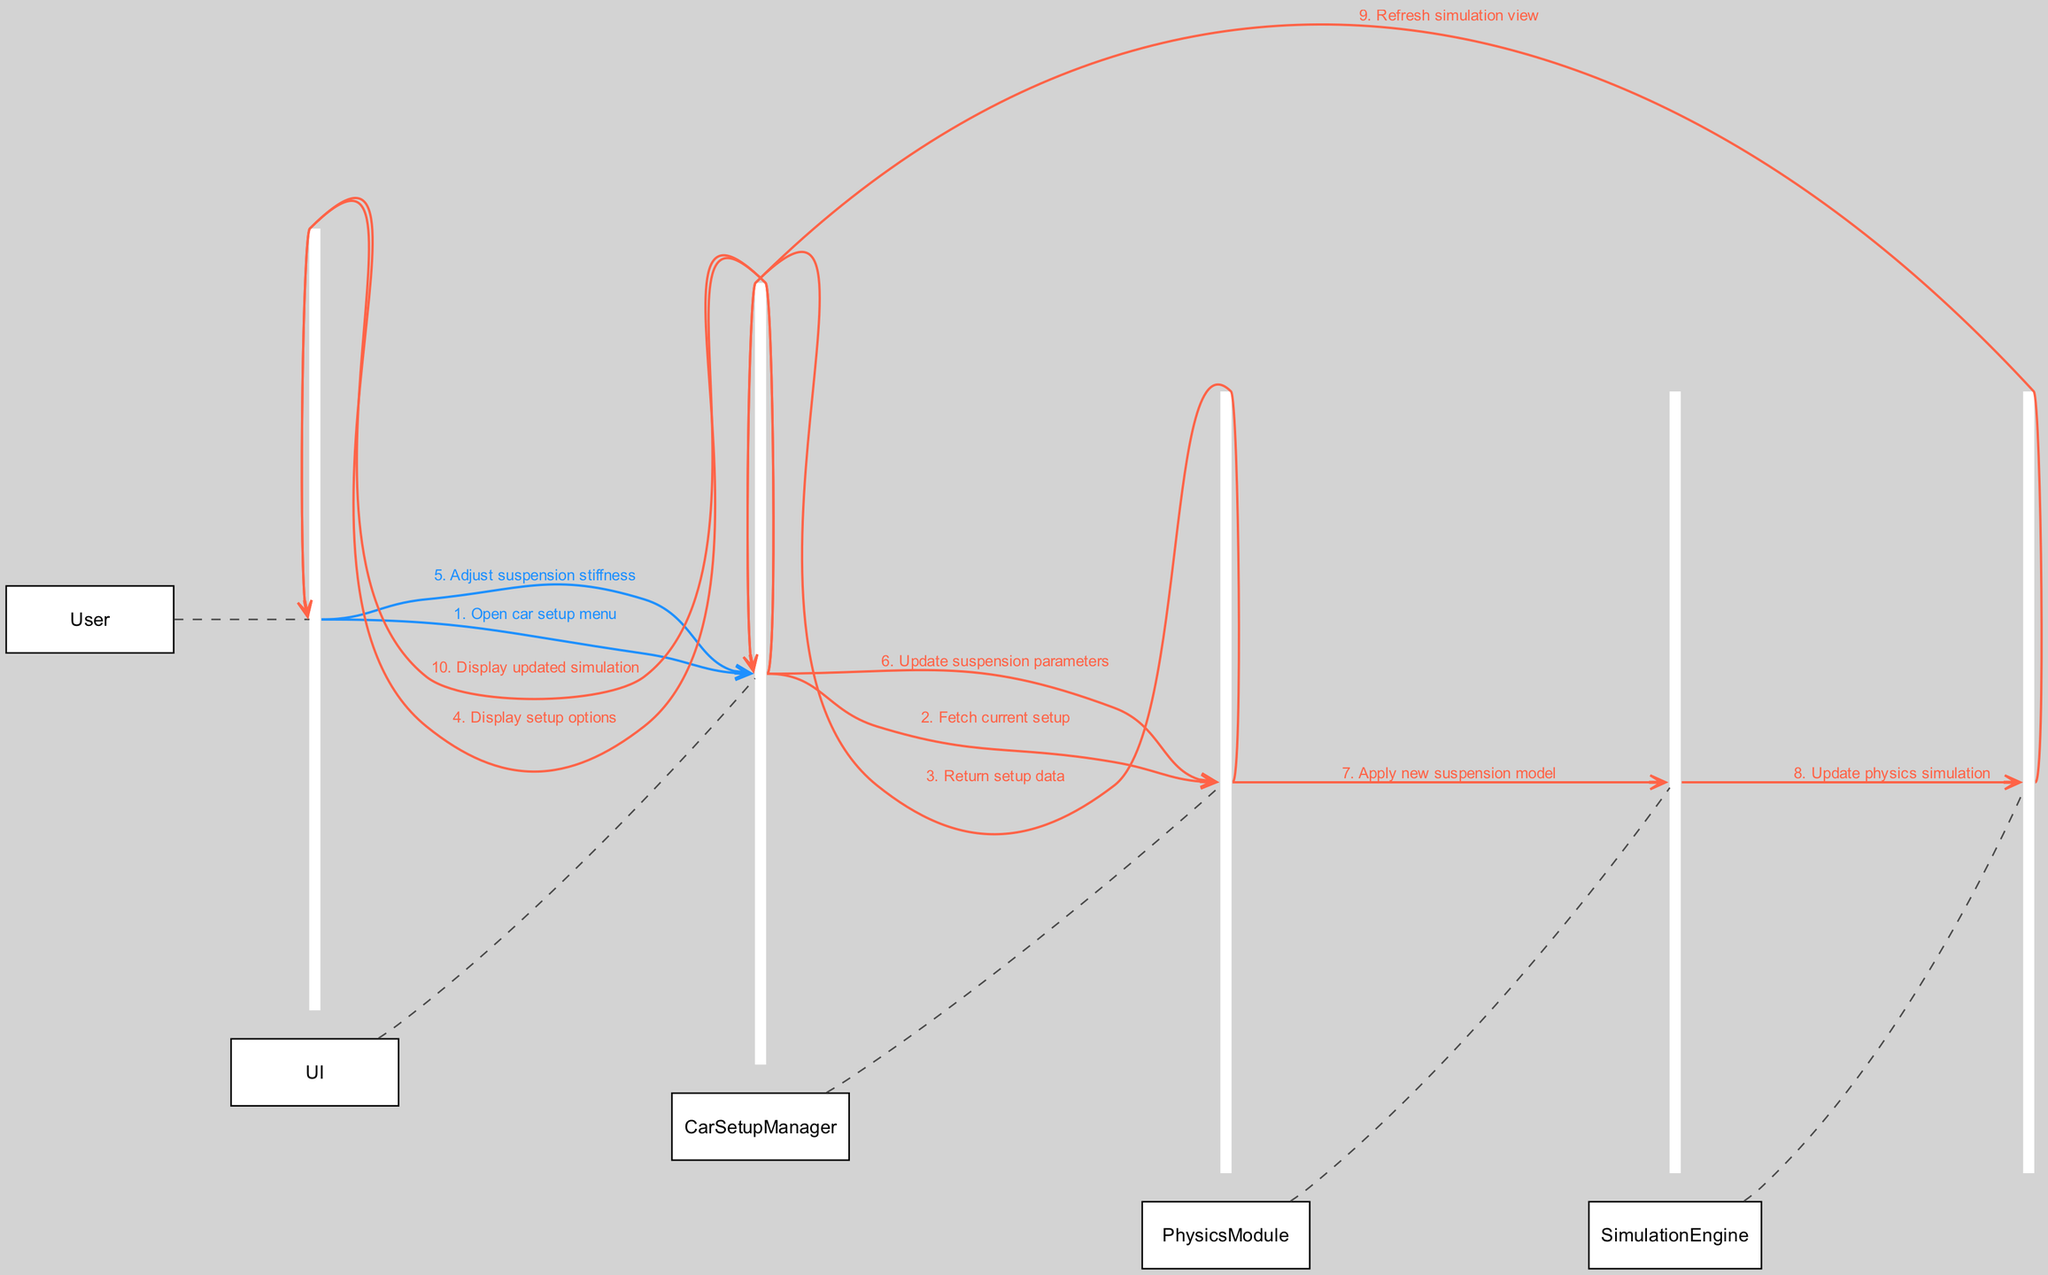What is the first action the User takes? The first action taken by the User is to "Open car setup menu" as shown in the first interaction in the sequence diagram.
Answer: Open car setup menu How many actors are involved in the interaction? By reviewing the list of actors, it can be seen that there are five actors: User, UI, SimulationEngine, PhysicsModule, and CarSetupManager.
Answer: Five What message does the UI send to the CarSetupManager? According to the interactions, the UI sends the message "Fetch current setup" to the CarSetupManager as part of the process.
Answer: Fetch current setup What action does the CarSetupManager take after receiving the suspension parameters update? After receiving the update, the CarSetupManager's action is to "Apply new suspension model" which is reflected in the relevant interaction.
Answer: Apply new suspension model Which actor is responsible for updating the physics simulation? The PhysicsModule is responsible for updating the physics simulation as indicated by the interaction where it communicates with the SimulationEngine.
Answer: PhysicsModule How is the updated simulation displayed to the User? The updated simulation is displayed to the User through the UI which sends the message "Display updated simulation" as the last step in the interaction flow.
Answer: Display updated simulation What is the last interaction in the sequence? The last interaction shown in the sequence diagram is the UI sending the message "Display updated simulation" to the User.
Answer: Display updated simulation How many messages are exchanged between the User and the UI? Examining the interactions, the User interacts with the UI at two different points in the sequence during the process of adjusting settings.
Answer: Two What role does the SimulationEngine play in the adjustment process? The SimulationEngine updates the physics simulation as per the information received from the PhysicsModule in the adjustment process.
Answer: Update physics simulation What does the CarSetupManager return to the UI after fetching? After fetching the current setup, the CarSetupManager returns "setup data" to the UI in response to the request made earlier.
Answer: Return setup data 